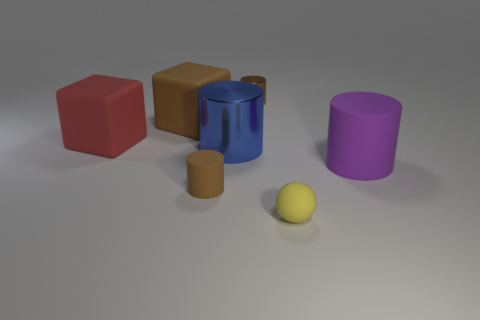Subtract all green balls. How many brown cylinders are left? 2 Subtract all blue metal cylinders. How many cylinders are left? 3 Subtract all blue cylinders. How many cylinders are left? 3 Add 1 large red spheres. How many objects exist? 8 Subtract all yellow cylinders. Subtract all red cubes. How many cylinders are left? 4 Subtract all blocks. How many objects are left? 5 Add 1 small objects. How many small objects are left? 4 Add 3 tiny spheres. How many tiny spheres exist? 4 Subtract 0 blue spheres. How many objects are left? 7 Subtract all small yellow matte things. Subtract all small brown cylinders. How many objects are left? 4 